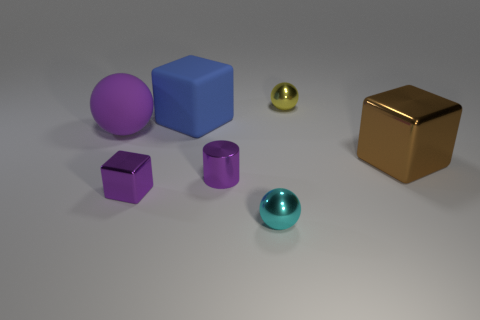Add 2 cyan objects. How many objects exist? 9 Subtract all metal blocks. How many blocks are left? 1 Subtract 1 blocks. How many blocks are left? 2 Subtract all balls. How many objects are left? 4 Add 4 small brown blocks. How many small brown blocks exist? 4 Subtract 0 brown cylinders. How many objects are left? 7 Subtract all cyan metallic things. Subtract all big rubber cubes. How many objects are left? 5 Add 7 tiny cyan metal balls. How many tiny cyan metal balls are left? 8 